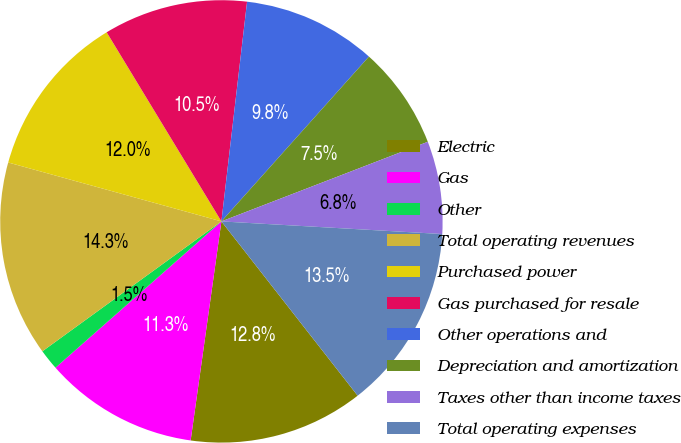Convert chart to OTSL. <chart><loc_0><loc_0><loc_500><loc_500><pie_chart><fcel>Electric<fcel>Gas<fcel>Other<fcel>Total operating revenues<fcel>Purchased power<fcel>Gas purchased for resale<fcel>Other operations and<fcel>Depreciation and amortization<fcel>Taxes other than income taxes<fcel>Total operating expenses<nl><fcel>12.78%<fcel>11.28%<fcel>1.51%<fcel>14.28%<fcel>12.03%<fcel>10.53%<fcel>9.77%<fcel>7.52%<fcel>6.77%<fcel>13.53%<nl></chart> 